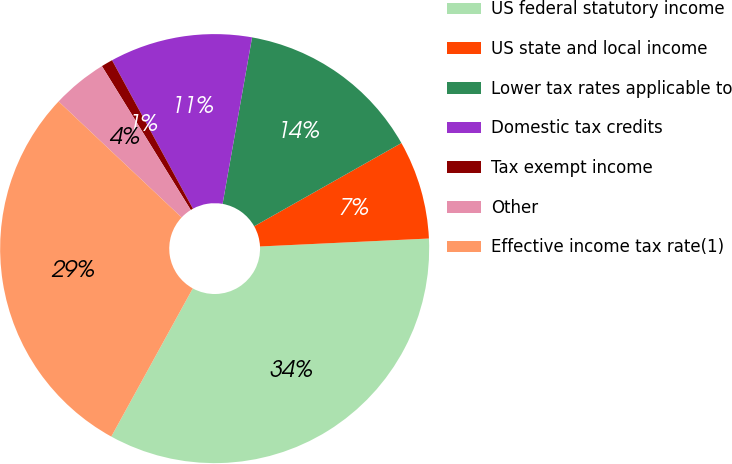<chart> <loc_0><loc_0><loc_500><loc_500><pie_chart><fcel>US federal statutory income<fcel>US state and local income<fcel>Lower tax rates applicable to<fcel>Domestic tax credits<fcel>Tax exempt income<fcel>Other<fcel>Effective income tax rate(1)<nl><fcel>33.75%<fcel>7.44%<fcel>14.02%<fcel>10.73%<fcel>0.87%<fcel>4.16%<fcel>29.03%<nl></chart> 